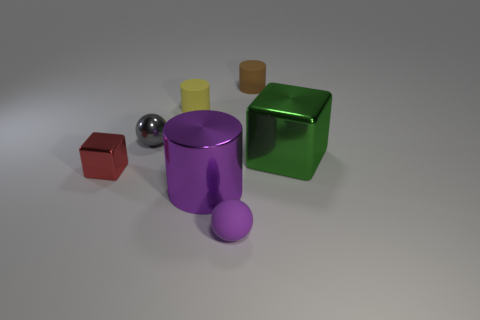Is there a large yellow thing that has the same material as the purple ball?
Keep it short and to the point. No. What number of big things are there?
Your response must be concise. 2. Is the material of the big green thing the same as the cylinder in front of the large green metal cube?
Give a very brief answer. Yes. What material is the object that is the same color as the big cylinder?
Your answer should be very brief. Rubber. What number of big cubes have the same color as the small metallic cube?
Give a very brief answer. 0. What size is the yellow object?
Your answer should be compact. Small. There is a small red object; does it have the same shape as the big metal object that is behind the purple metallic object?
Ensure brevity in your answer.  Yes. What color is the other cube that is the same material as the big green cube?
Offer a terse response. Red. There is a shiny block left of the small yellow object; how big is it?
Offer a terse response. Small. Are there fewer red shiny things in front of the large purple metal thing than brown rubber objects?
Make the answer very short. Yes. 